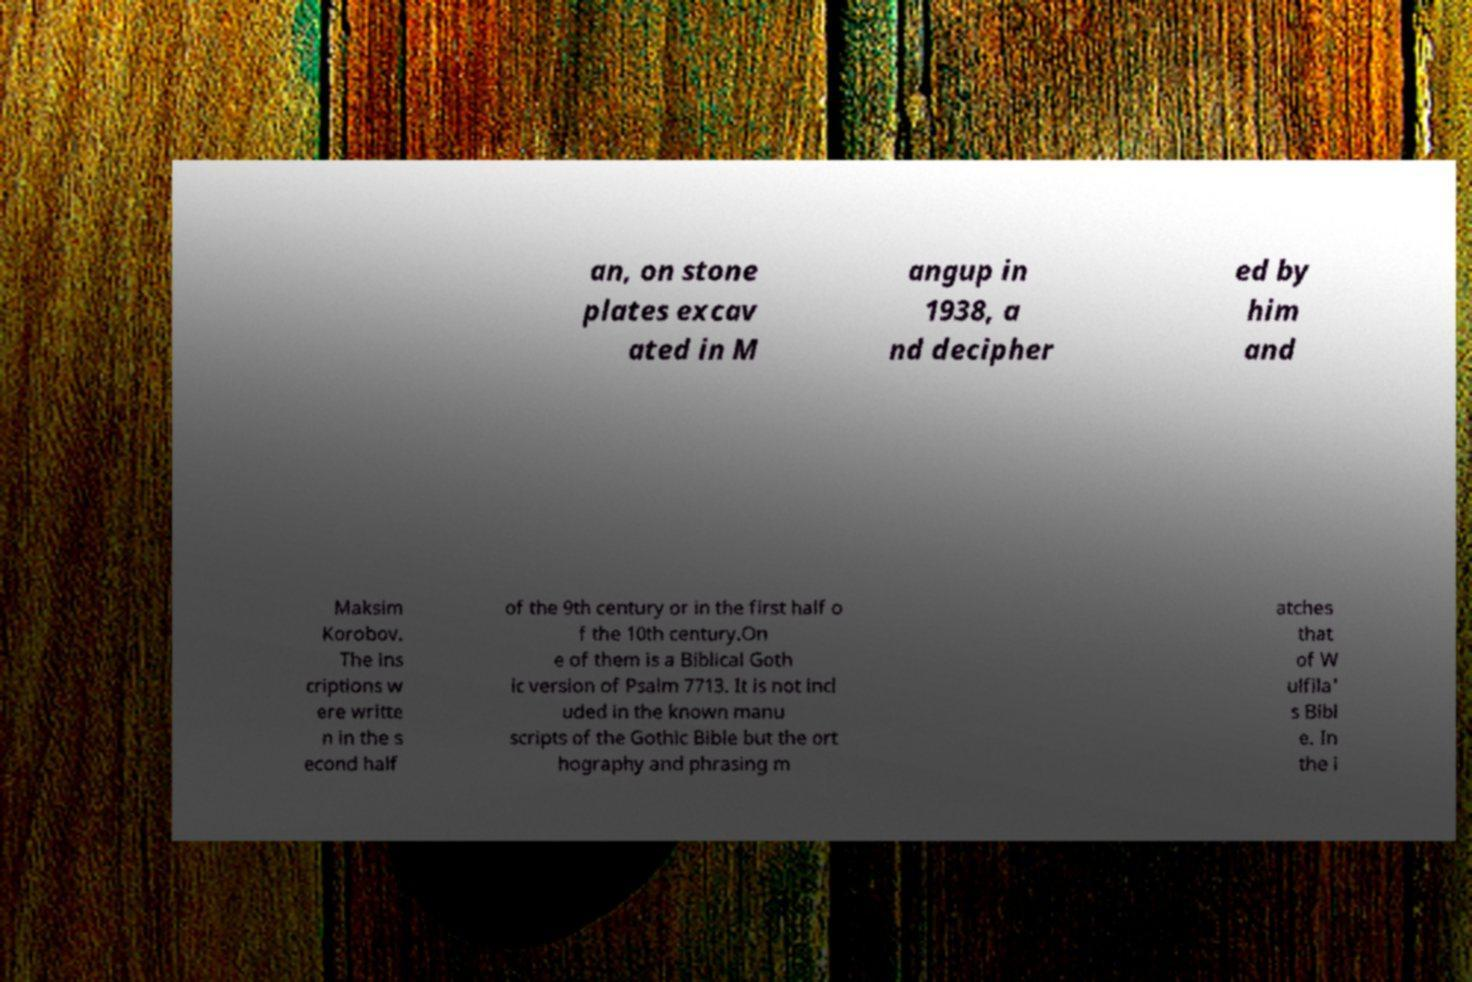For documentation purposes, I need the text within this image transcribed. Could you provide that? an, on stone plates excav ated in M angup in 1938, a nd decipher ed by him and Maksim Korobov. The ins criptions w ere writte n in the s econd half of the 9th century or in the first half o f the 10th century.On e of them is a Biblical Goth ic version of Psalm 7713. It is not incl uded in the known manu scripts of the Gothic Bible but the ort hography and phrasing m atches that of W ulfila' s Bibl e. In the i 